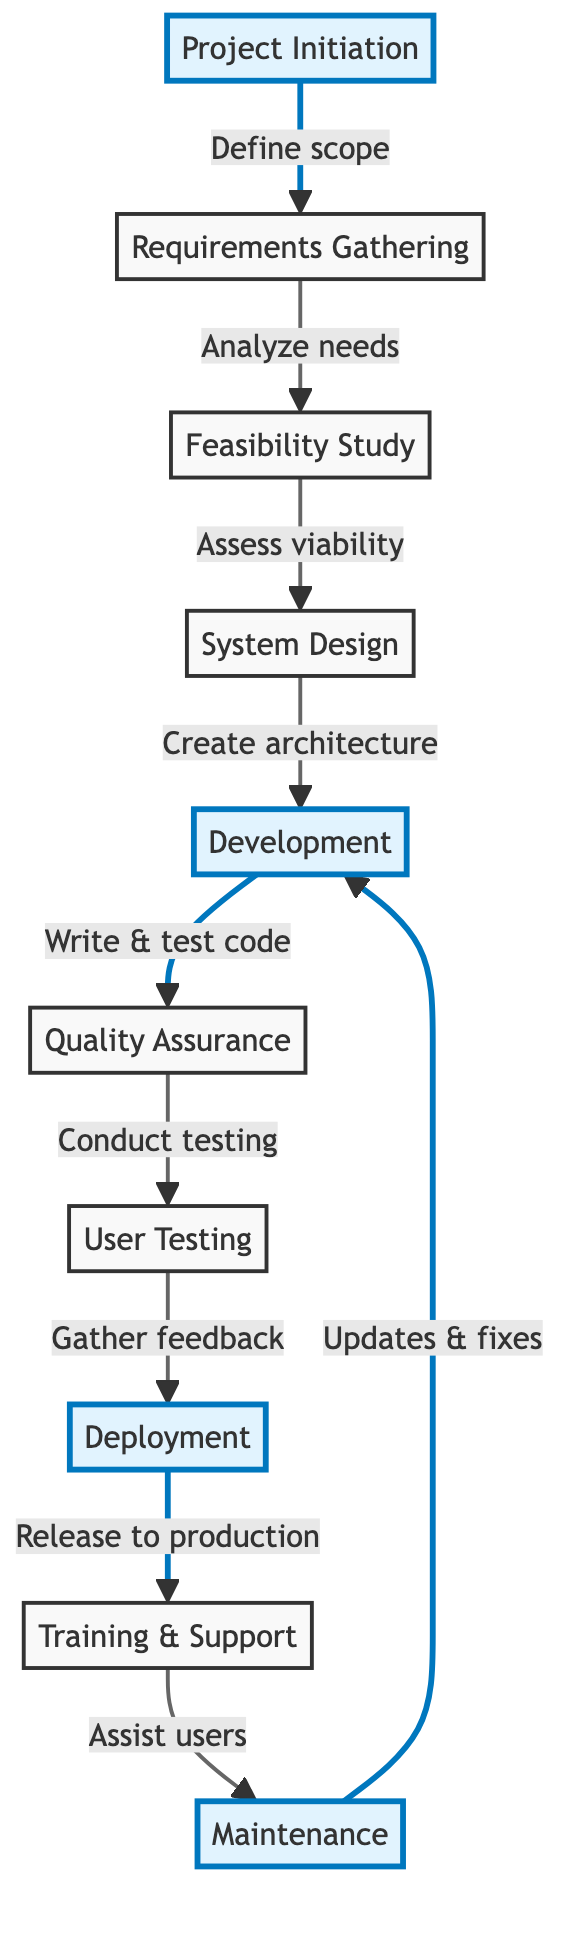What is the starting point of the project lifecycle? The diagram begins with "Project Initiation," which defines project scope and objectives.
Answer: Project Initiation How many nodes are there in the diagram? As per the diagram, there are ten distinct nodes representing different stages of the software development lifecycle.
Answer: Ten What follows "User Testing" in the flow? After "User Testing," the flow proceeds to "Deployment," indicating the transition from testing to releasing the software.
Answer: Deployment What is the main function of "Quality Assurance"? "Quality Assurance" conducts testing to ensure that the software meets the specified requirements.
Answer: Conducting testing Which two nodes are highlighted in the diagram? The highlighted nodes are "Project Initiation" and "Development," indicating their significance in the lifecycle.
Answer: Project Initiation, Development What happens after the "Deployment" phase? Following the "Deployment" phase, the workflow proceeds to "Training & Support," which involves assisting users with the newly deployed software.
Answer: Training & Support What is the task during the "Maintenance" phase? The "Maintenance" phase involves performing updates and bug fixes post-deployment to ensure the software remains functional and up to date.
Answer: Updates & fixes Which phase assesses technical and financial viability? The phase that assesses technical and financial viability is called "Feasibility Study."
Answer: Feasibility Study How do the phases relate to each other in the lifecycle? The phases follow a linear progression, with each phase building upon the results of the previous phase, illustrating a sequential workflow in software development.
Answer: Linear progression 